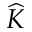<formula> <loc_0><loc_0><loc_500><loc_500>\widehat { K }</formula> 